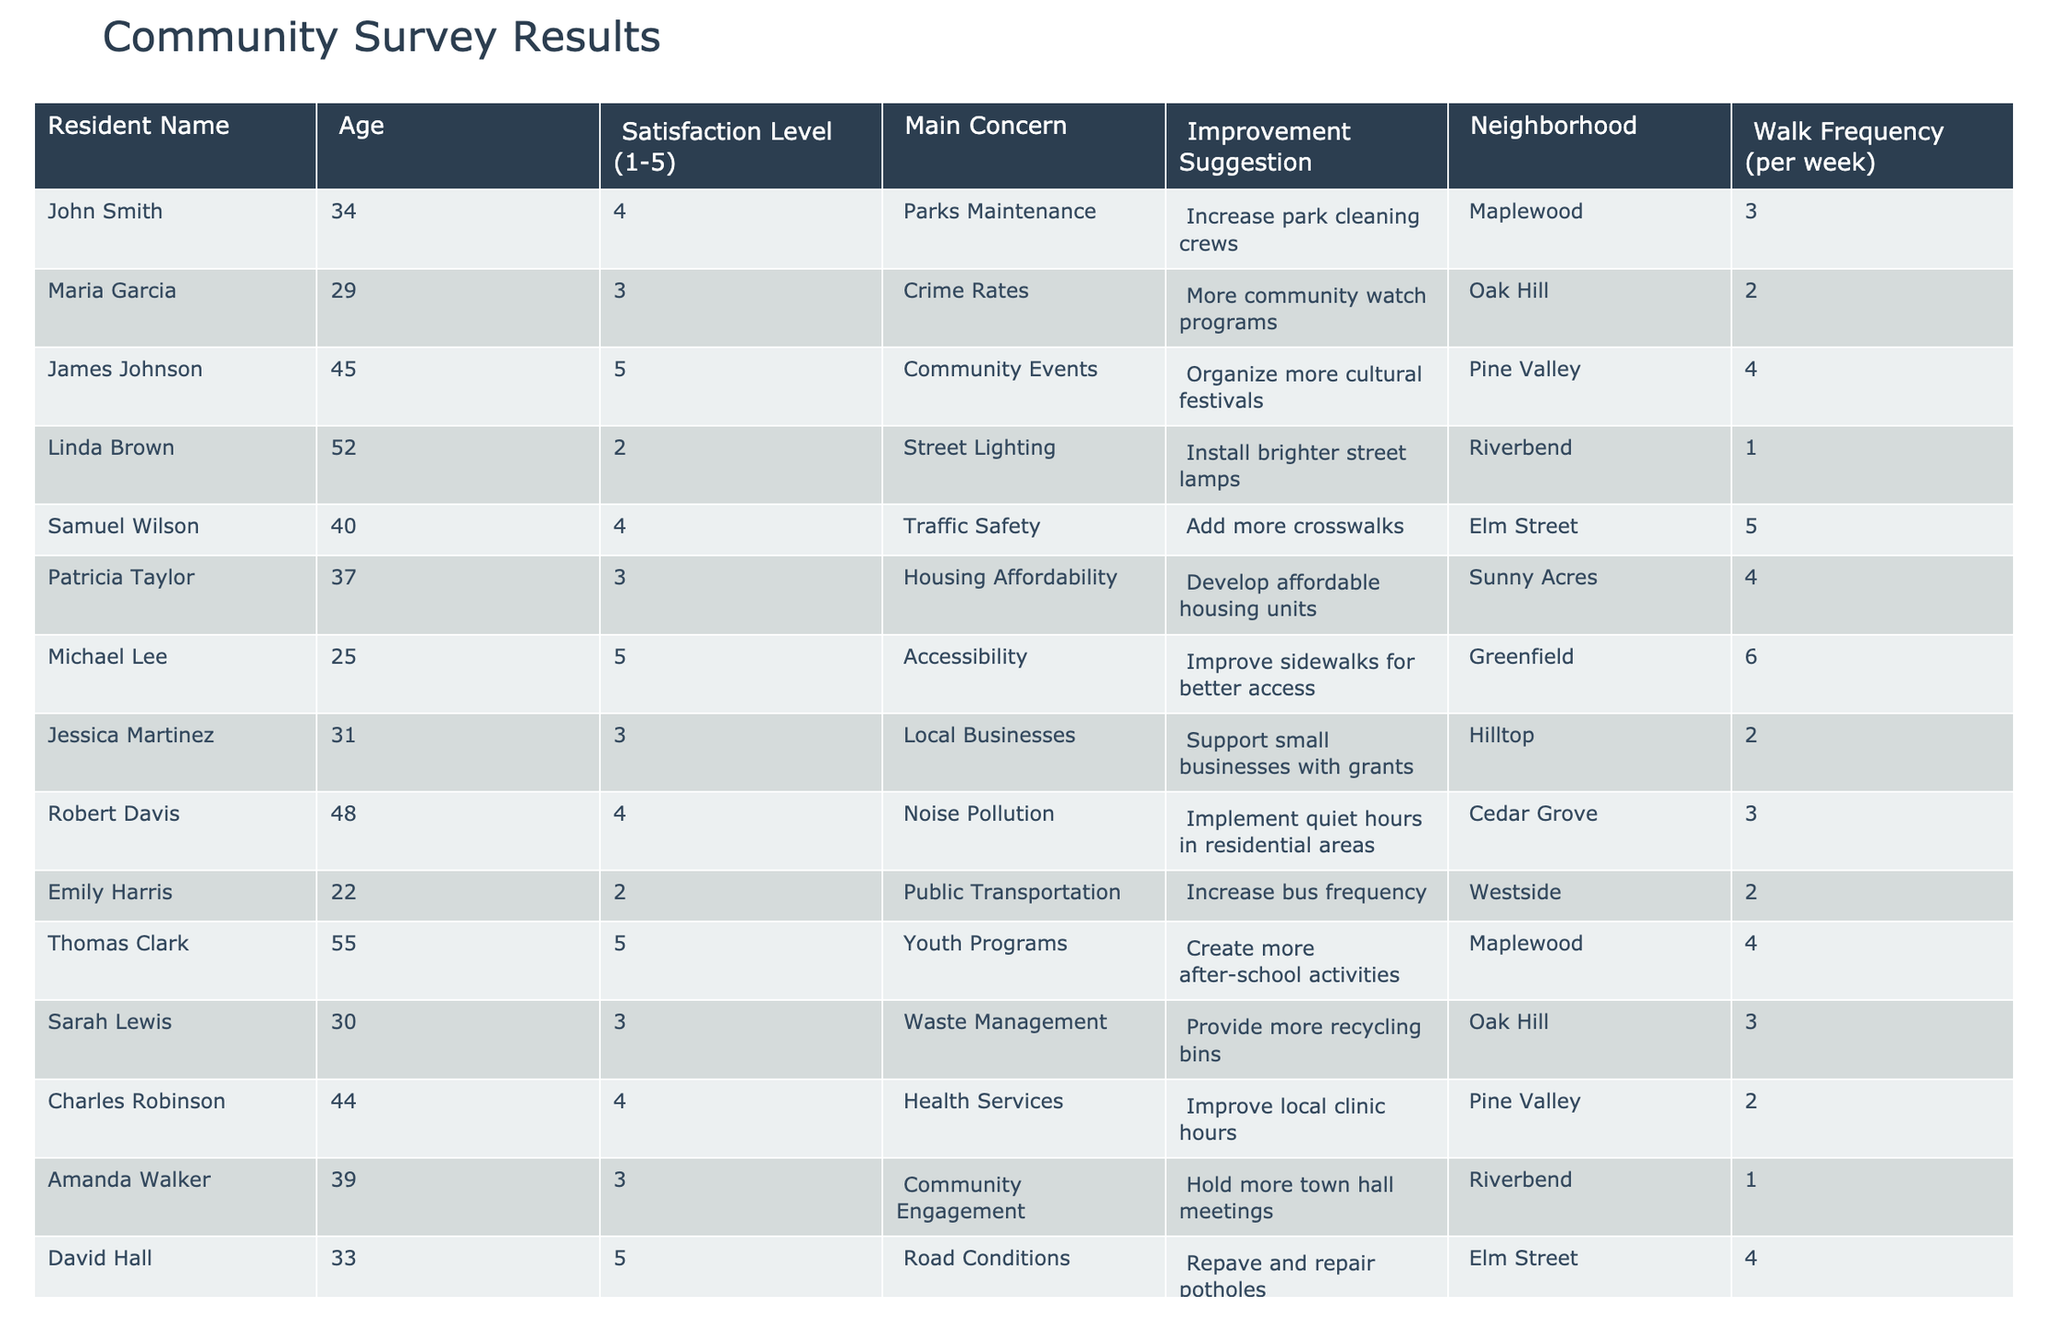What is the average satisfaction level of the residents? To calculate the average satisfaction level, we add all the satisfaction levels: (4 + 3 + 5 + 2 + 4 + 3 + 5 + 3 + 4 + 2 + 5 + 3 + 4 + 3 + 5) =  54. Then, we divide this sum by the number of residents (15): 54 / 15 = 3.6
Answer: 3.6 Which resident has the highest satisfaction level? Looking at the satisfaction levels, both Michael Lee and Thomas Clark have a satisfaction level of 5, which is the highest.
Answer: Michael Lee and Thomas Clark How many residents have a concern about crime rates? The table shows one resident, Maria Garcia, who has expressed a concern about crime rates.
Answer: 1 What is the main concern of residents who rated their satisfaction as 2? Residents who rated their satisfaction at level 2 are Linda Brown, Emily Harris, and Nancy Allen. Their main concerns are street lighting, public transportation, and vegetation and tree care, respectively.
Answer: Street lighting, public transportation, vegetation and tree care How many residents suggested improvements related to community events? James Johnson and Amanda Walker provided suggestions focused on community events. Hence, there are two residents with such suggestions.
Answer: 2 Is there a resident who walks more than 5 times a week? The data shows that Michael Lee walks 6 times a week, indicating that there is at least one resident with this frequency.
Answer: Yes What is the total number of improvement suggestions provided in the table? Counting all unique suggestions from each resident, we find 15 individual suggestions listed.
Answer: 15 What percentage of residents is satisfied with a level of 4 or higher? There are 8 residents with a satisfaction level of 4 or higher out of 15 total residents. To find the percentage, we calculate: (8 / 15) * 100 = 53.33%.
Answer: 53.33% Which concern is most commonly mentioned by residents who rated their satisfaction level as 3? The main concerns for residents with a satisfaction level of 3 are crime rates, local businesses, housing affordability, waste management, and community engagement totaling five different concerns mentioned.
Answer: Crime rates, local businesses, housing affordability, waste management, community engagement Identify the neighborhood with the highest average satisfaction level? By calculating the average satisfaction level per neighborhood, we find that Maplewood (satisfaction levels 4 and 5) has an average of 4.5, which is the highest compared to others.
Answer: Maplewood 